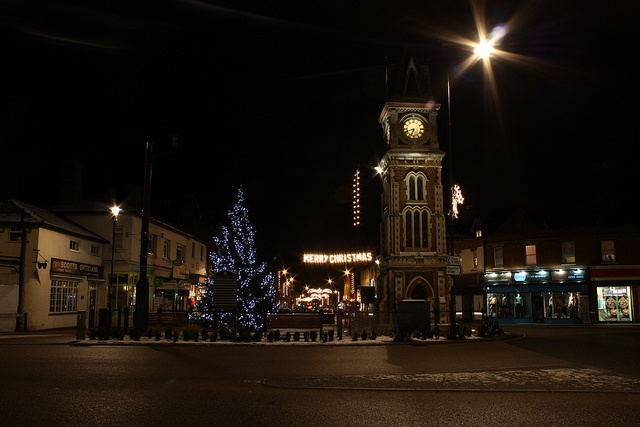Describe the objects in this image and their specific colors. I can see bench in black, maroon, and gray tones, bench in black tones, clock in black, khaki, and tan tones, and clock in black, olive, and tan tones in this image. 